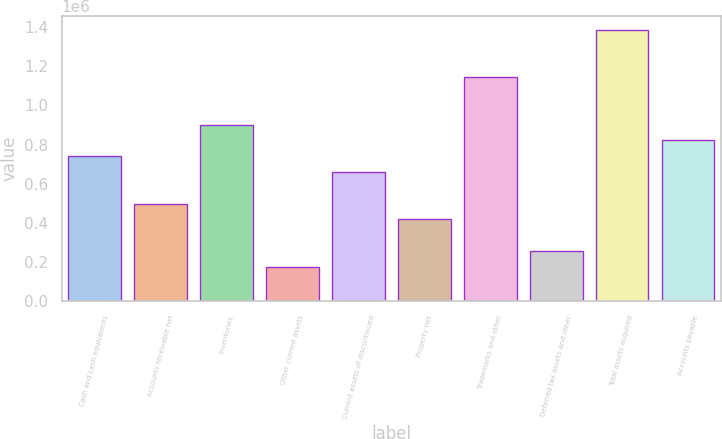Convert chart to OTSL. <chart><loc_0><loc_0><loc_500><loc_500><bar_chart><fcel>Cash and cash equivalents<fcel>Accounts receivable net<fcel>Inventories<fcel>Other current assets<fcel>Current assets of discontinued<fcel>Property net<fcel>Trademarks and other<fcel>Deferred tax assets and other<fcel>Total assets acquired<fcel>Accounts payable<nl><fcel>741140<fcel>498948<fcel>902602<fcel>176025<fcel>660410<fcel>418218<fcel>1.14479e+06<fcel>256756<fcel>1.38699e+06<fcel>821871<nl></chart> 